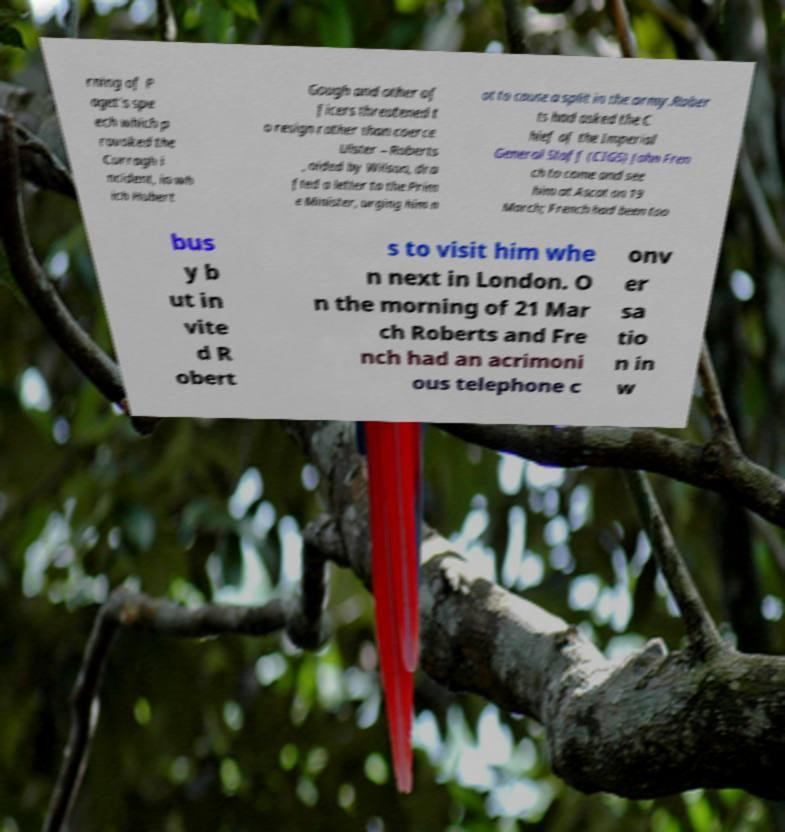Please identify and transcribe the text found in this image. rning of P aget's spe ech which p rovoked the Curragh i ncident, in wh ich Hubert Gough and other of ficers threatened t o resign rather than coerce Ulster – Roberts , aided by Wilson, dra fted a letter to the Prim e Minister, urging him n ot to cause a split in the army.Rober ts had asked the C hief of the Imperial General Staff (CIGS) John Fren ch to come and see him at Ascot on 19 March; French had been too bus y b ut in vite d R obert s to visit him whe n next in London. O n the morning of 21 Mar ch Roberts and Fre nch had an acrimoni ous telephone c onv er sa tio n in w 